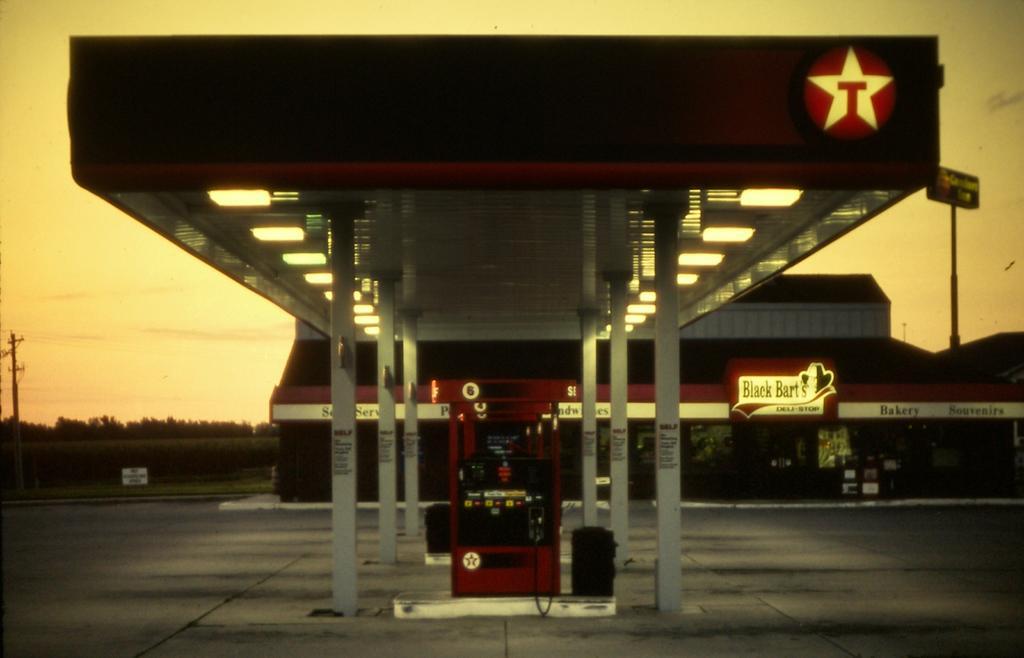Could you give a brief overview of what you see in this image? In the center of the image we can see a petrol filling station, in which we can see lights, poles, one petrol filling machine, one black color object and a logo. In the background, we can see the sky, one building, trees, poles and a few other objects. 